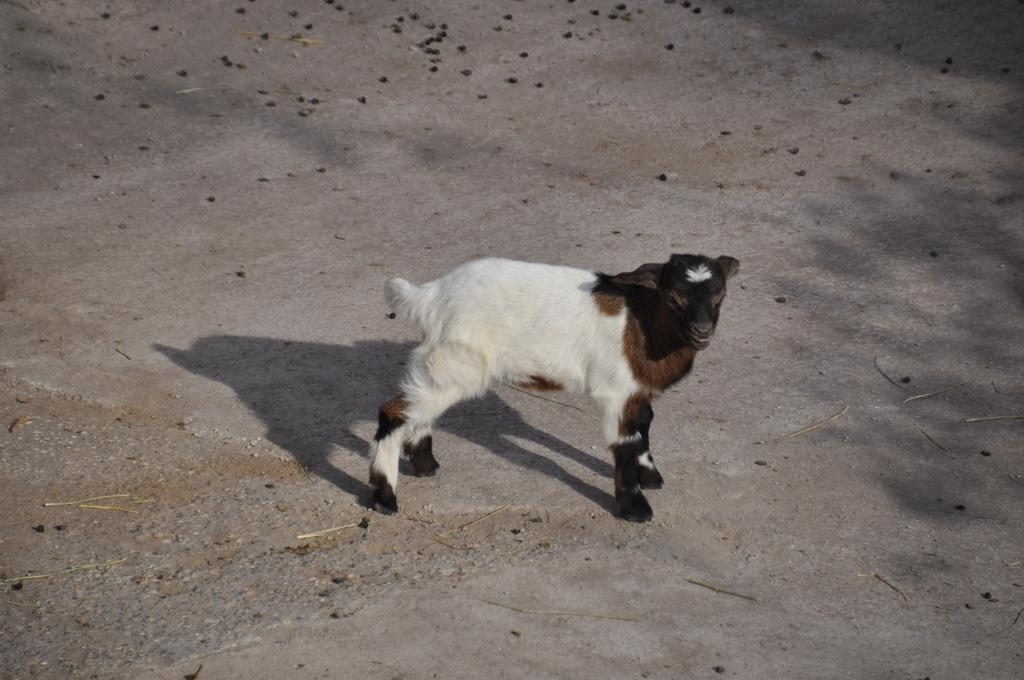What animal is present in the image? There is a goat in the image. Where is the goat located in the image? The goat is on the ground. What is the goat's memory limit in the image? There is no information about the goat's memory limit in the image. 